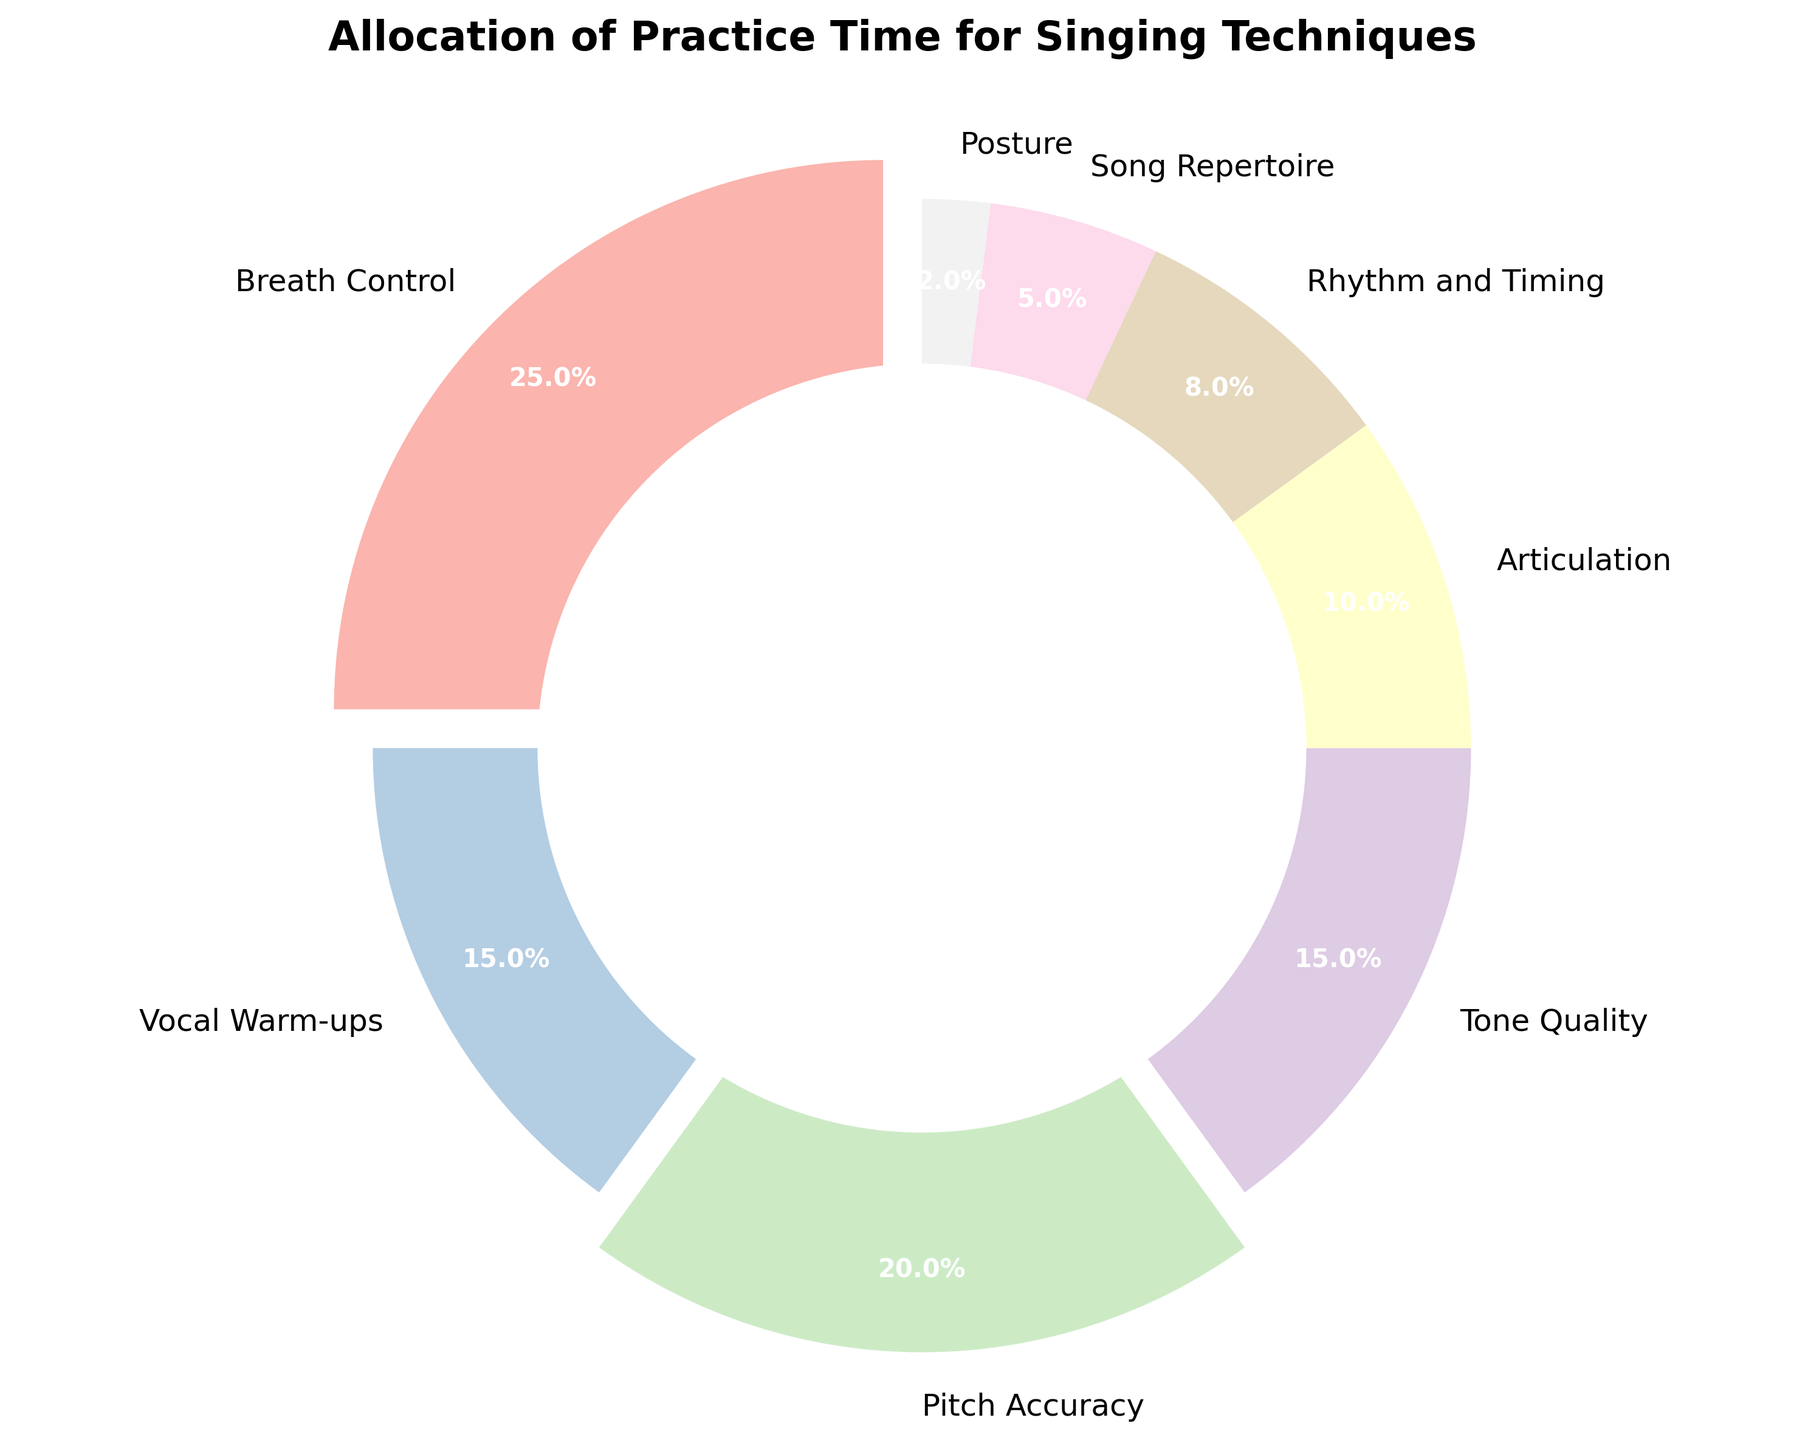what is the total percentage of time allocated to Breath Control and Pitch Accuracy? To find the total percentage of time allocated to Breath Control and Pitch Accuracy, we simply add their respective percentages: 25% (Breath Control) + 20% (Pitch Accuracy) = 45%.
Answer: 45% which technique is assigned the least amount of practice time? By observing the chart, the technique with the smallest percentage is 2%. The label corresponding to this percentage is Posture.
Answer: Posture how much more practice time is allocated to Vocal Warm-ups compared to Song Repertoire? To determine the difference in practice time between Vocal Warm-ups and Song Repertoire, we subtract the percentage of Song Repertoire from Vocal Warm-ups: 15% (Vocal Warm-ups) - 5% (Song Repertoire) = 10%.
Answer: 10% which techniques have more than 15% of practice time allocated? From the chart, we can see that the techniques with more than 15% practice time are Breath Control (25%) and Pitch Accuracy (20%).
Answer: Breath Control, Pitch Accuracy what is the combined percentage for Articulation and Rhythm and Timing? By adding the percentages for Articulation and Rhythm and Timing, we get: 10% (Articulation) + 8% (Rhythm and Timing) = 18%.
Answer: 18% does any technique have exactly 15% of practice time allocation? By looking at the chart, we observe that both Vocal Warm-ups and Tone Quality are allocated exactly 15% of practice time each.
Answer: Vocal Warm-ups, Tone Quality is the percentage allocated to Pitch Accuracy greater than Tone Quality? By comparing the percentages given, Pitch Accuracy is 20%, and Tone Quality is 15%. Since 20% is greater than 15%, the answer is yes.
Answer: Yes if we were to double the practice time for Posture, what would be its new percentage? Doubling the practice time for Posture means multiplying its percentage by 2. Given that Posture is 2%, we get 2% * 2 = 4%.
Answer: 4% how much less practice time is allocated to Posture compared to Breath Control? To find the difference between Breath Control and Posture, we subtract the percentage of Posture from Breath Control: 25% (Breath Control) - 2% (Posture) = 23%.
Answer: 23% which techniques use less than 10% of practice time? By reviewing the chart, the only technique with less than 10% of practice time is Song Repertoire (5%) and Posture (2%).
Answer: Song Repertoire, Posture 